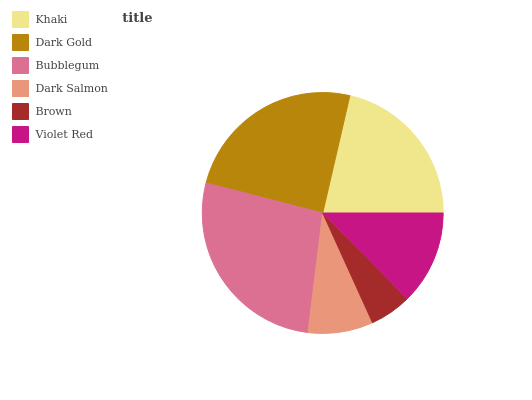Is Brown the minimum?
Answer yes or no. Yes. Is Bubblegum the maximum?
Answer yes or no. Yes. Is Dark Gold the minimum?
Answer yes or no. No. Is Dark Gold the maximum?
Answer yes or no. No. Is Dark Gold greater than Khaki?
Answer yes or no. Yes. Is Khaki less than Dark Gold?
Answer yes or no. Yes. Is Khaki greater than Dark Gold?
Answer yes or no. No. Is Dark Gold less than Khaki?
Answer yes or no. No. Is Khaki the high median?
Answer yes or no. Yes. Is Violet Red the low median?
Answer yes or no. Yes. Is Dark Salmon the high median?
Answer yes or no. No. Is Khaki the low median?
Answer yes or no. No. 